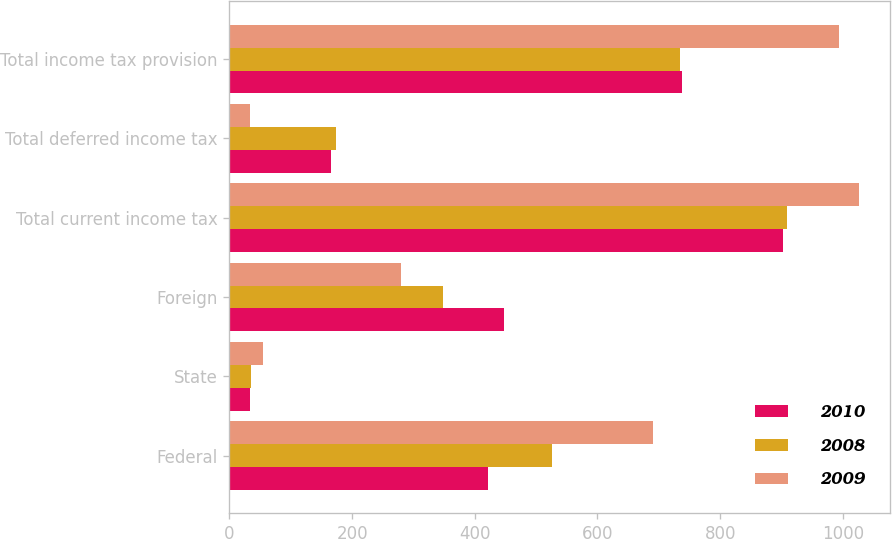Convert chart. <chart><loc_0><loc_0><loc_500><loc_500><stacked_bar_chart><ecel><fcel>Federal<fcel>State<fcel>Foreign<fcel>Total current income tax<fcel>Total deferred income tax<fcel>Total income tax provision<nl><fcel>2010<fcel>421<fcel>34<fcel>448<fcel>903<fcel>165<fcel>738<nl><fcel>2008<fcel>526<fcel>35<fcel>348<fcel>909<fcel>174<fcel>735<nl><fcel>2009<fcel>691<fcel>55<fcel>280<fcel>1026<fcel>33<fcel>993<nl></chart> 